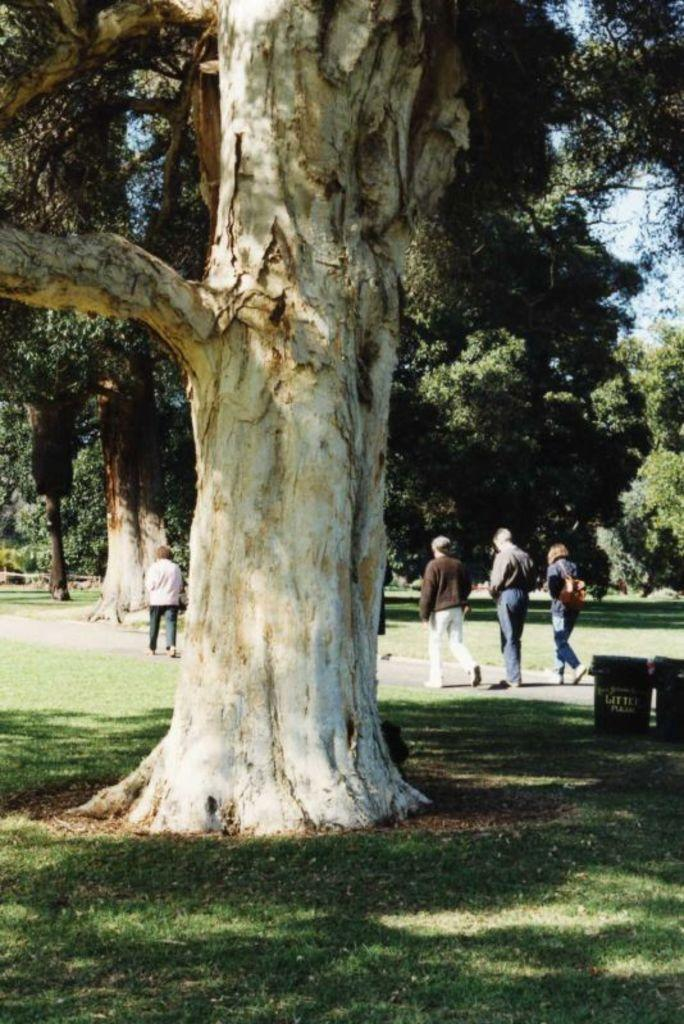What is located at the bottom of the image? There is a tree at the bottom of the image. What are the people in the image doing? There are persons walking in the middle of the image. What can be seen in the background of the image? There are other trees in the background of the image. What type of soup is being served in the frame of the image? There is no soup or frame present in the image; it features a tree and people walking. 